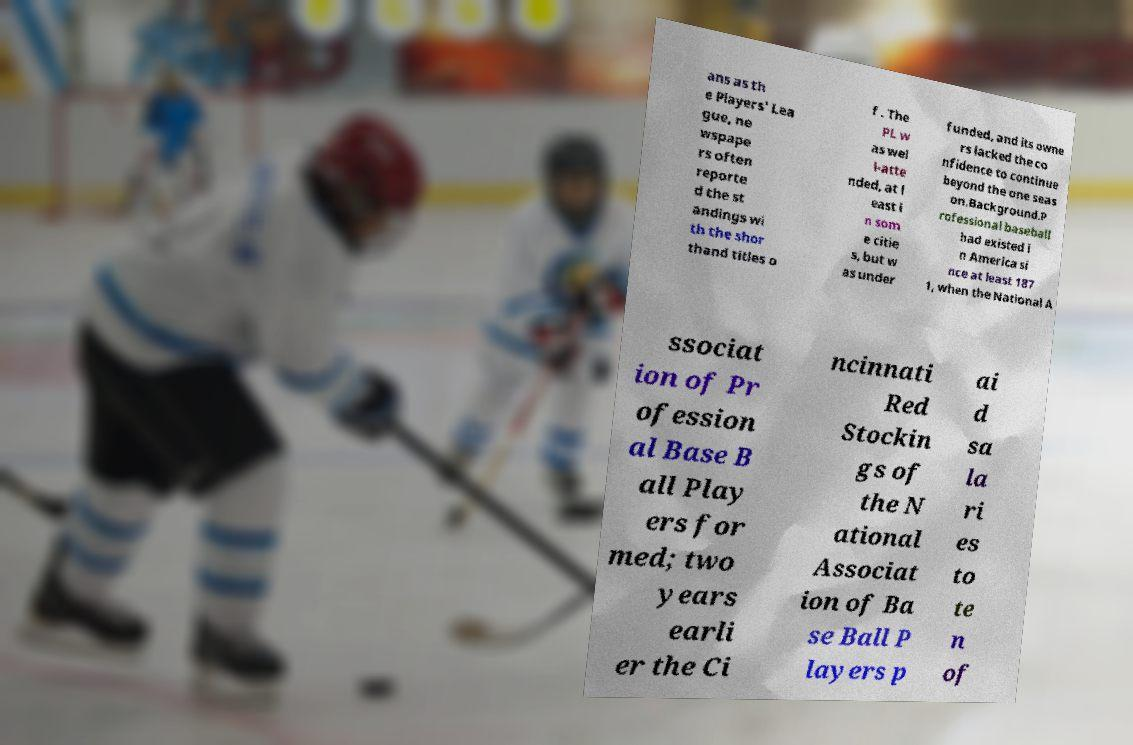What messages or text are displayed in this image? I need them in a readable, typed format. ans as th e Players' Lea gue, ne wspape rs often reporte d the st andings wi th the shor thand titles o f . The PL w as wel l-atte nded, at l east i n som e citie s, but w as under funded, and its owne rs lacked the co nfidence to continue beyond the one seas on.Background.P rofessional baseball had existed i n America si nce at least 187 1, when the National A ssociat ion of Pr ofession al Base B all Play ers for med; two years earli er the Ci ncinnati Red Stockin gs of the N ational Associat ion of Ba se Ball P layers p ai d sa la ri es to te n of 